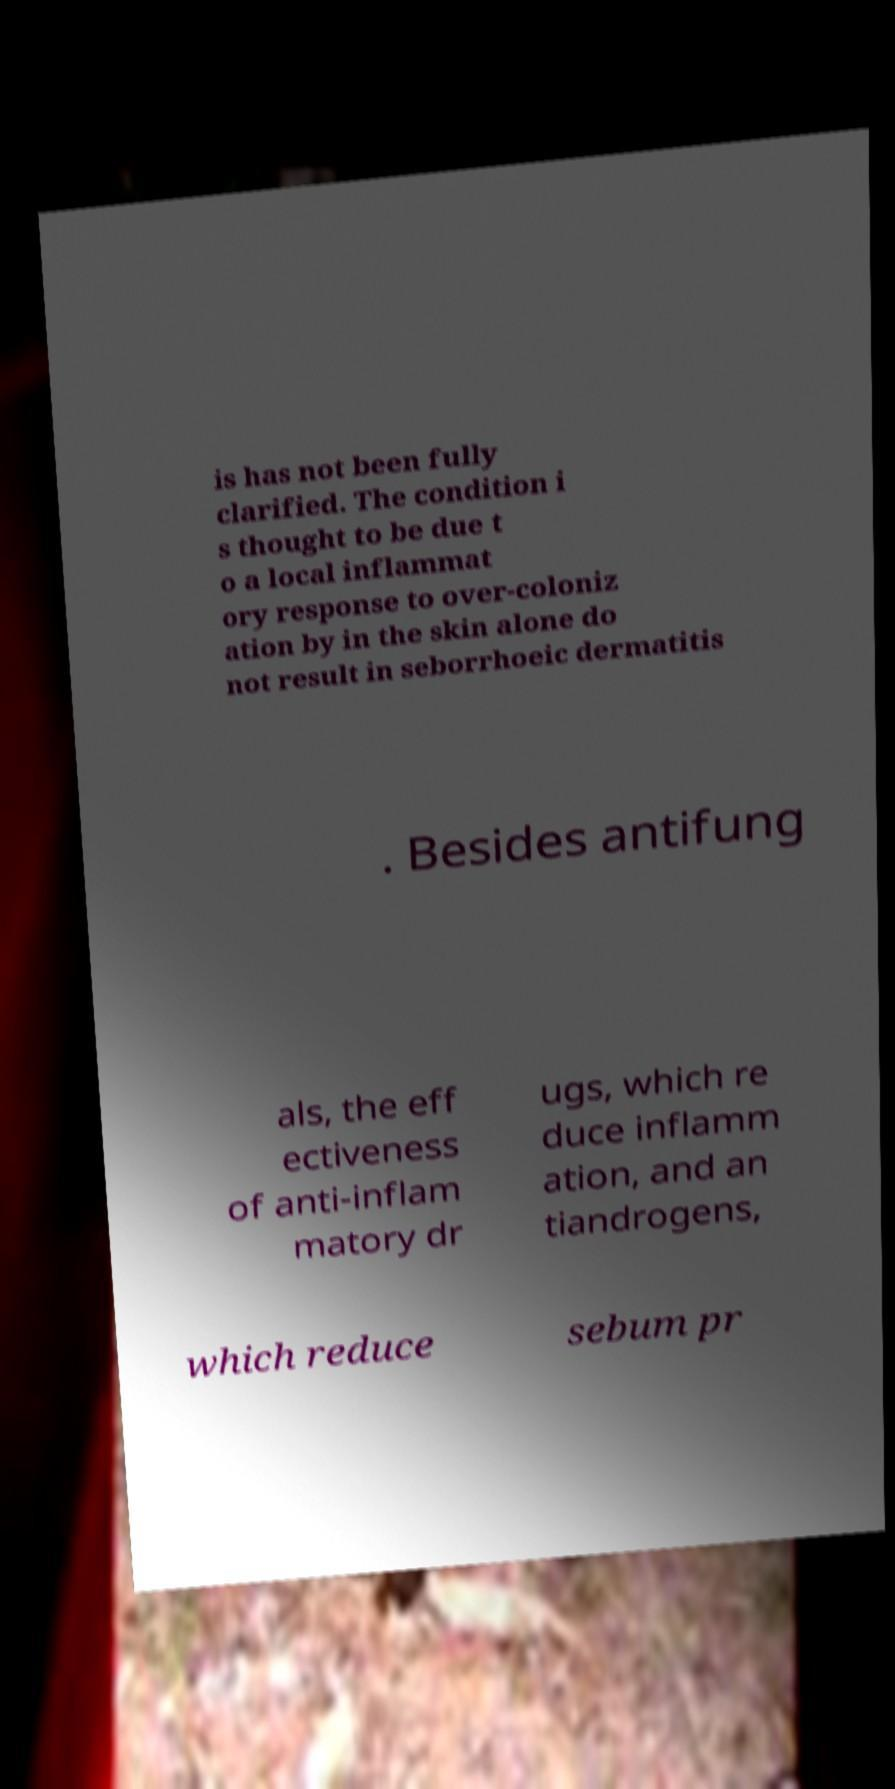Could you assist in decoding the text presented in this image and type it out clearly? is has not been fully clarified. The condition i s thought to be due t o a local inflammat ory response to over-coloniz ation by in the skin alone do not result in seborrhoeic dermatitis . Besides antifung als, the eff ectiveness of anti-inflam matory dr ugs, which re duce inflamm ation, and an tiandrogens, which reduce sebum pr 